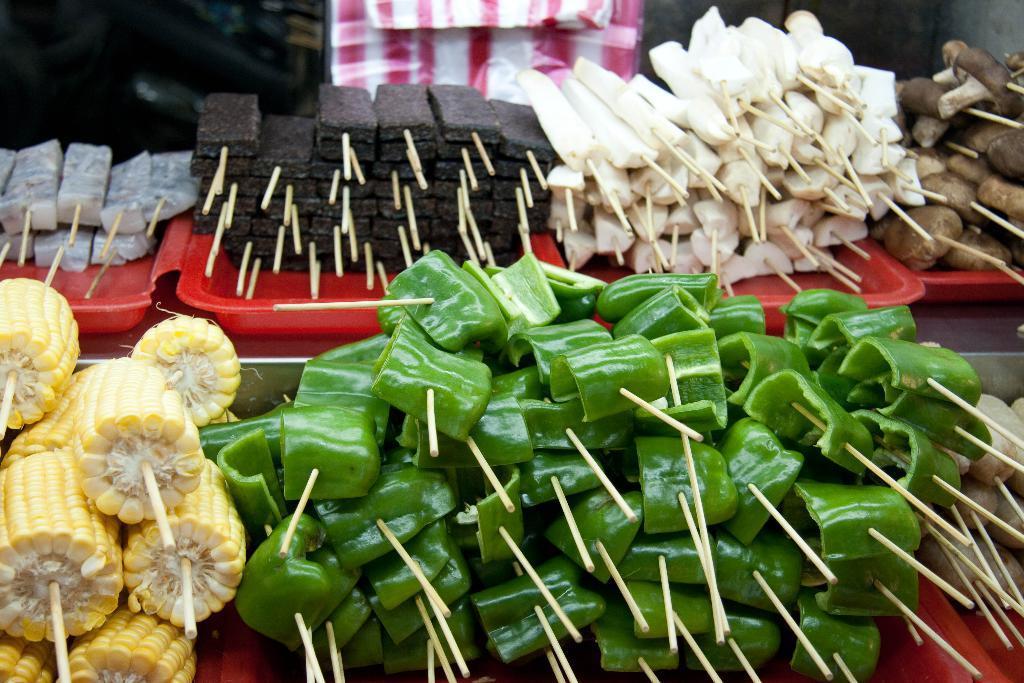Please provide a concise description of this image. In this picture we can see some food items on the trays. There are a few objects visible in the background. Background is blurry. 